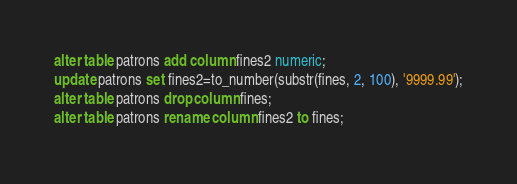<code> <loc_0><loc_0><loc_500><loc_500><_SQL_>alter table patrons add column fines2 numeric;
update patrons set fines2=to_number(substr(fines, 2, 100), '9999.99');
alter table patrons drop column fines;
alter table patrons rename column fines2 to fines;
</code> 